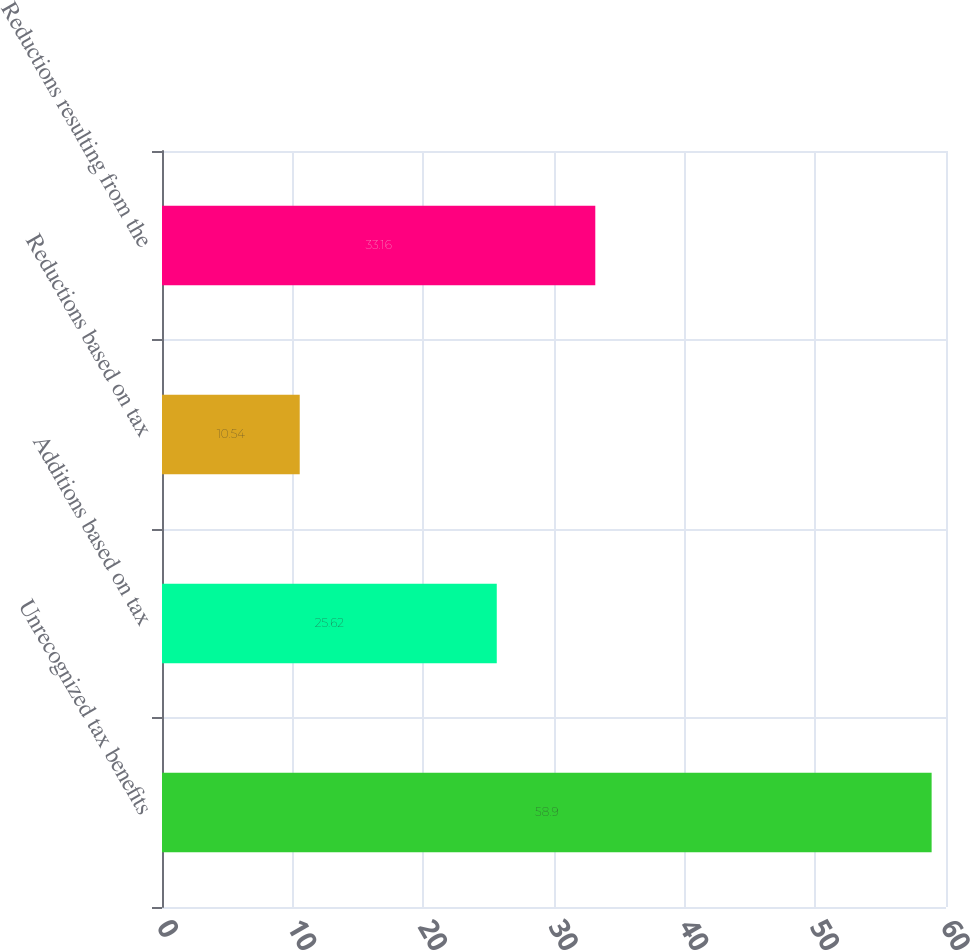<chart> <loc_0><loc_0><loc_500><loc_500><bar_chart><fcel>Unrecognized tax benefits<fcel>Additions based on tax<fcel>Reductions based on tax<fcel>Reductions resulting from the<nl><fcel>58.9<fcel>25.62<fcel>10.54<fcel>33.16<nl></chart> 